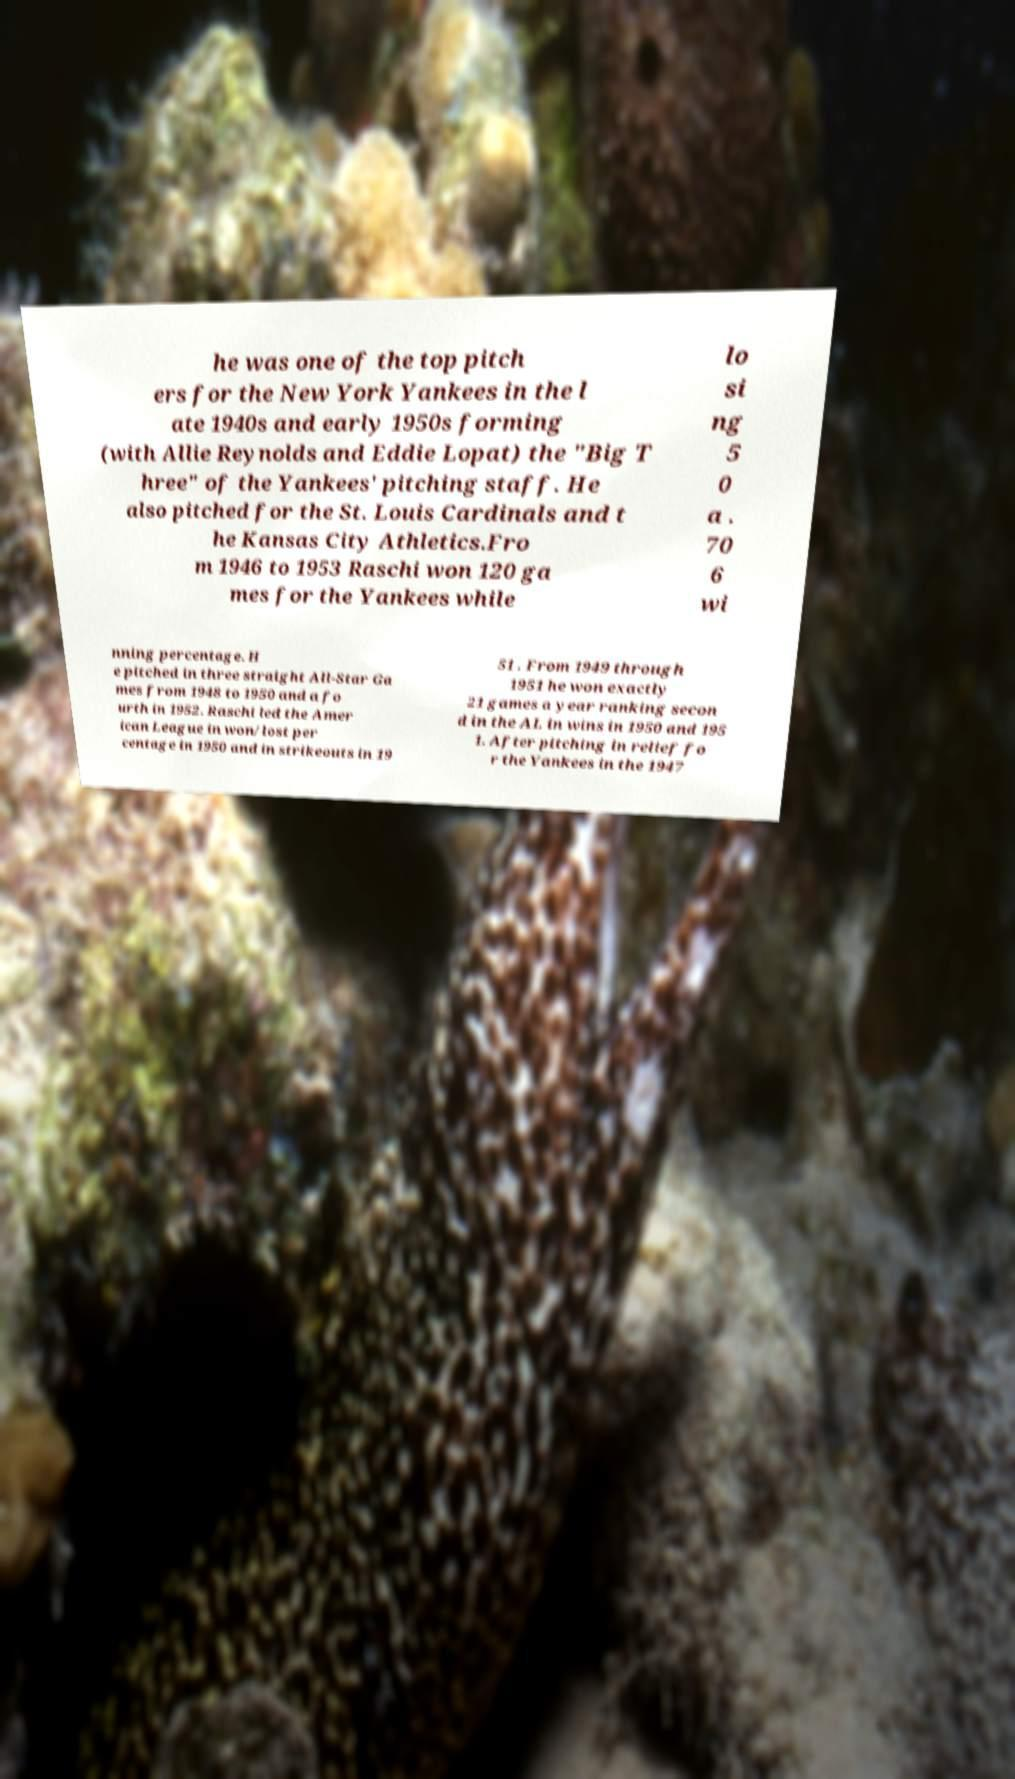Please identify and transcribe the text found in this image. he was one of the top pitch ers for the New York Yankees in the l ate 1940s and early 1950s forming (with Allie Reynolds and Eddie Lopat) the "Big T hree" of the Yankees' pitching staff. He also pitched for the St. Louis Cardinals and t he Kansas City Athletics.Fro m 1946 to 1953 Raschi won 120 ga mes for the Yankees while lo si ng 5 0 a . 70 6 wi nning percentage. H e pitched in three straight All-Star Ga mes from 1948 to 1950 and a fo urth in 1952. Raschi led the Amer ican League in won/lost per centage in 1950 and in strikeouts in 19 51 . From 1949 through 1951 he won exactly 21 games a year ranking secon d in the AL in wins in 1950 and 195 1. After pitching in relief fo r the Yankees in the 1947 